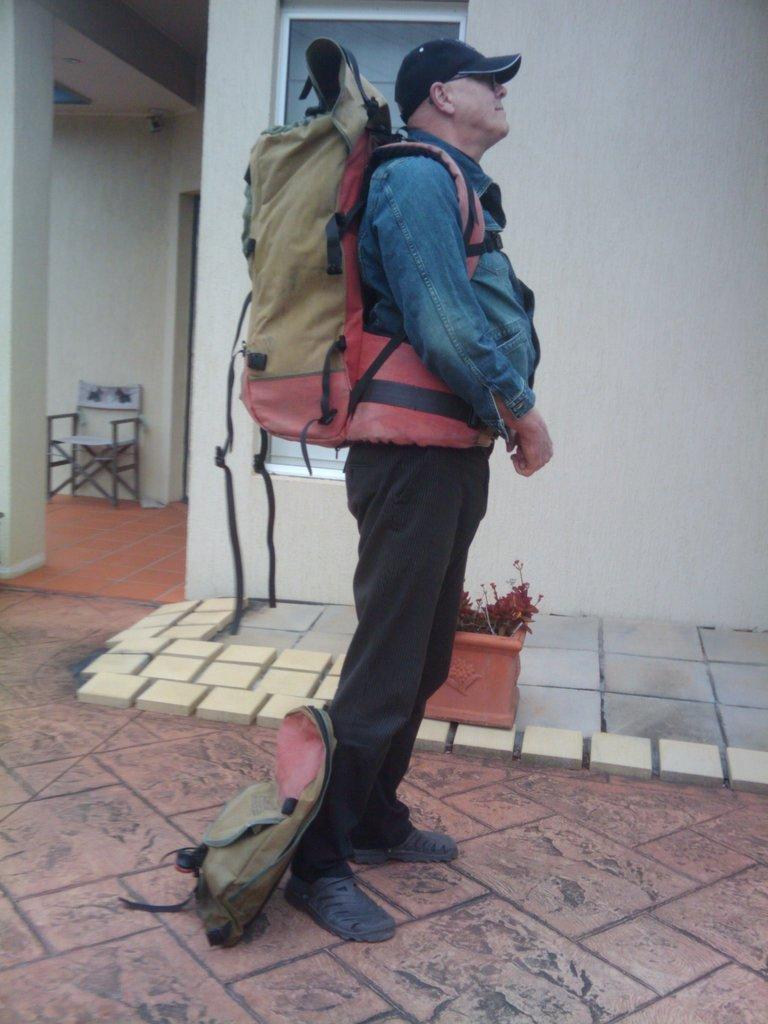How would you summarize this image in a sentence or two? In the image we can see there is a man who is standing and he is carrying a travelling backpack. He is wearing a cap and jacket. Beside him on the footpath there is a pot in which there is a plants. Behind the pot there is a wall which is of white colour and there is a window on it. Beside the wall there is a chair which is attached to the wall. 